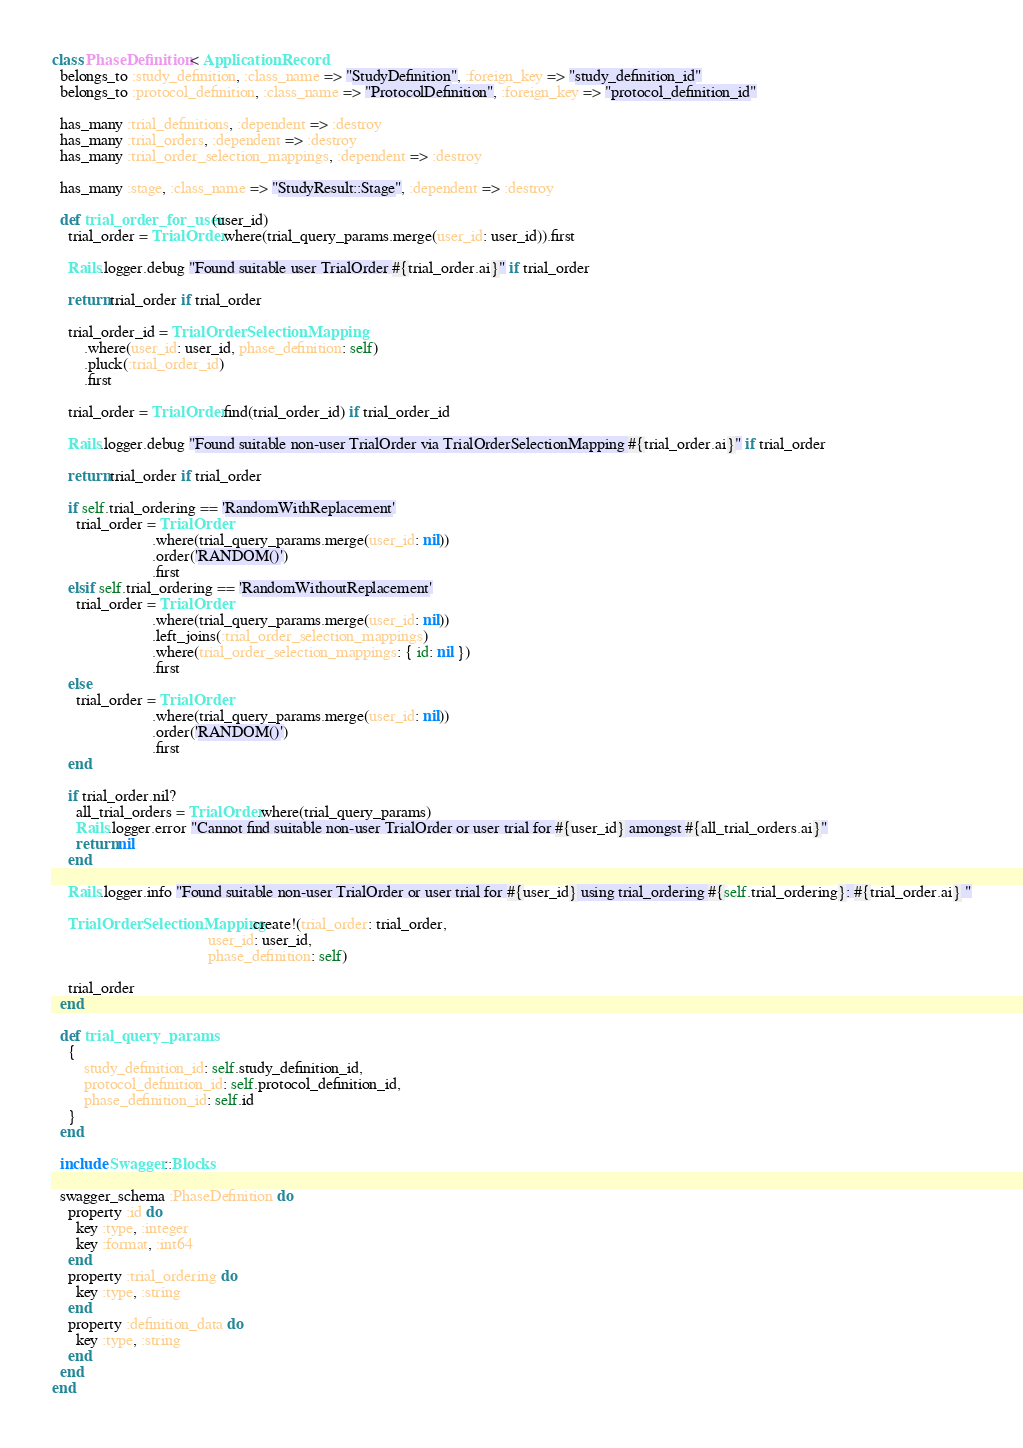<code> <loc_0><loc_0><loc_500><loc_500><_Ruby_>class PhaseDefinition < ApplicationRecord
  belongs_to :study_definition, :class_name => "StudyDefinition", :foreign_key => "study_definition_id"
  belongs_to :protocol_definition, :class_name => "ProtocolDefinition", :foreign_key => "protocol_definition_id"

  has_many :trial_definitions, :dependent => :destroy
  has_many :trial_orders, :dependent => :destroy
  has_many :trial_order_selection_mappings, :dependent => :destroy

  has_many :stage, :class_name => "StudyResult::Stage", :dependent => :destroy

  def trial_order_for_user(user_id)
    trial_order = TrialOrder.where(trial_query_params.merge(user_id: user_id)).first

    Rails.logger.debug "Found suitable user TrialOrder #{trial_order.ai}" if trial_order

    return trial_order if trial_order

    trial_order_id = TrialOrderSelectionMapping
        .where(user_id: user_id, phase_definition: self)
        .pluck(:trial_order_id)
        .first

    trial_order = TrialOrder.find(trial_order_id) if trial_order_id

    Rails.logger.debug "Found suitable non-user TrialOrder via TrialOrderSelectionMapping #{trial_order.ai}" if trial_order

    return trial_order if trial_order

    if self.trial_ordering == 'RandomWithReplacement'
      trial_order = TrialOrder
                         .where(trial_query_params.merge(user_id: nil))
                         .order('RANDOM()')
                         .first
    elsif self.trial_ordering == 'RandomWithoutReplacement'
      trial_order = TrialOrder
                         .where(trial_query_params.merge(user_id: nil))
                         .left_joins(:trial_order_selection_mappings)
                         .where(trial_order_selection_mappings: { id: nil })
                         .first
    else
      trial_order = TrialOrder
                         .where(trial_query_params.merge(user_id: nil))
                         .order('RANDOM()')
                         .first
    end

    if trial_order.nil?
      all_trial_orders = TrialOrder.where(trial_query_params)
      Rails.logger.error "Cannot find suitable non-user TrialOrder or user trial for #{user_id} amongst #{all_trial_orders.ai}"
      return nil
    end

    Rails.logger.info "Found suitable non-user TrialOrder or user trial for #{user_id} using trial_ordering #{self.trial_ordering}: #{trial_order.ai} "

    TrialOrderSelectionMapping.create!(trial_order: trial_order,
                                       user_id: user_id,
                                       phase_definition: self)

    trial_order
  end

  def trial_query_params
    {
        study_definition_id: self.study_definition_id,
        protocol_definition_id: self.protocol_definition_id,
        phase_definition_id: self.id
    }
  end

  include Swagger::Blocks

  swagger_schema :PhaseDefinition do
    property :id do
      key :type, :integer
      key :format, :int64
    end
    property :trial_ordering do
      key :type, :string
    end
    property :definition_data do
      key :type, :string
    end
  end
end
</code> 